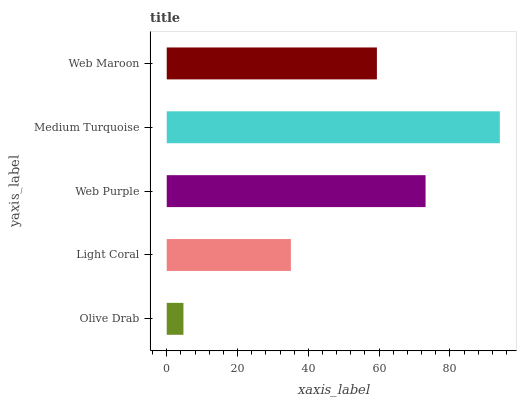Is Olive Drab the minimum?
Answer yes or no. Yes. Is Medium Turquoise the maximum?
Answer yes or no. Yes. Is Light Coral the minimum?
Answer yes or no. No. Is Light Coral the maximum?
Answer yes or no. No. Is Light Coral greater than Olive Drab?
Answer yes or no. Yes. Is Olive Drab less than Light Coral?
Answer yes or no. Yes. Is Olive Drab greater than Light Coral?
Answer yes or no. No. Is Light Coral less than Olive Drab?
Answer yes or no. No. Is Web Maroon the high median?
Answer yes or no. Yes. Is Web Maroon the low median?
Answer yes or no. Yes. Is Medium Turquoise the high median?
Answer yes or no. No. Is Web Purple the low median?
Answer yes or no. No. 